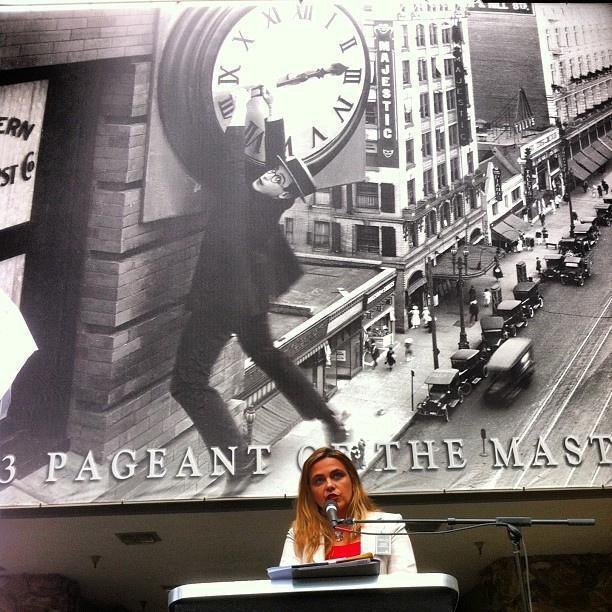How many people can be seen?
Give a very brief answer. 2. 